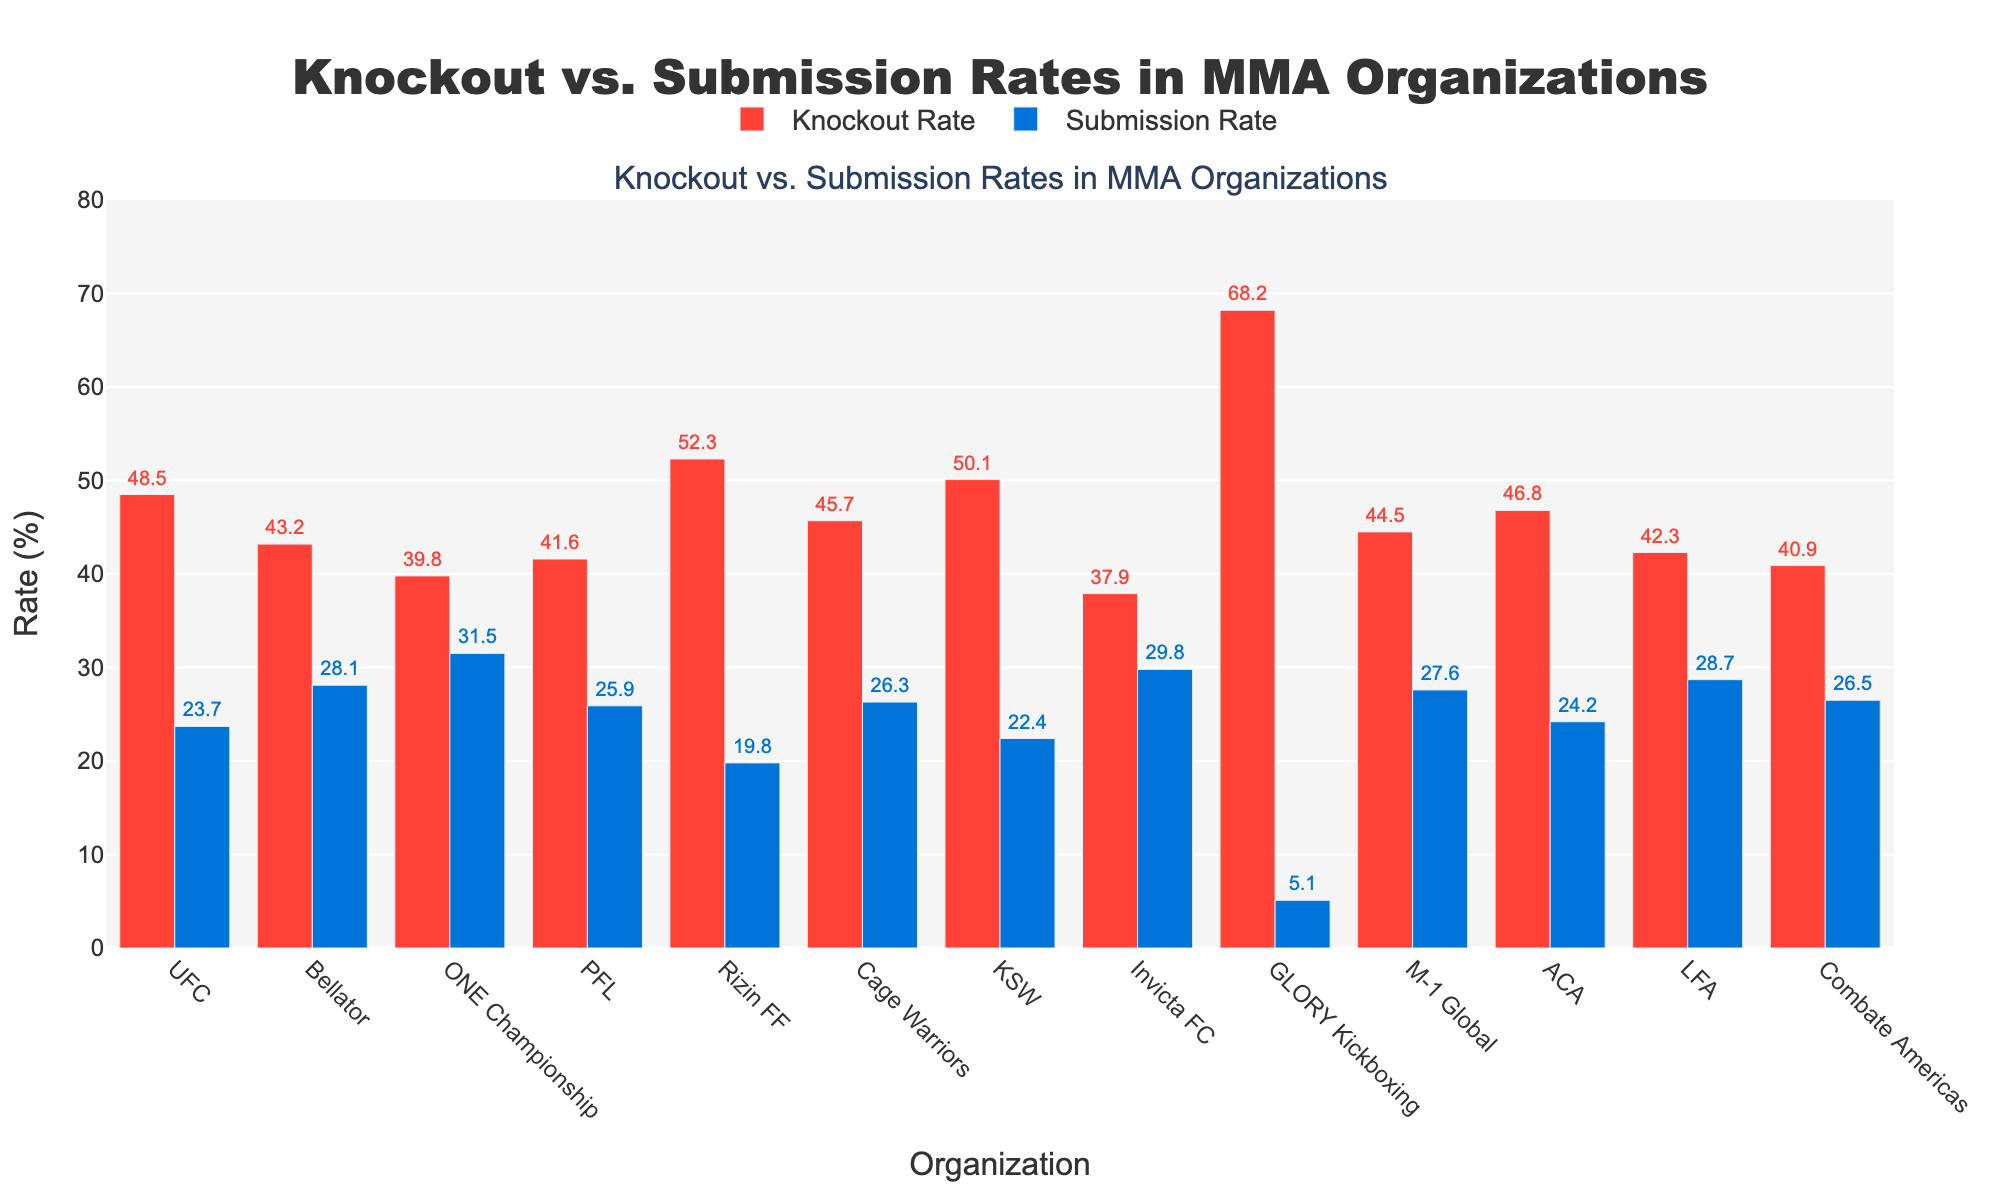Which organization has the highest knockout rate? GLORY Kickboxing has the highest knockout rate at 68.2%. This is evident as the red bar is the tallest among all the knockout rates for the organizations listed.
Answer: GLORY Kickboxing Which organization has the lowest submission rate? The organization with the lowest submission rate is GLORY Kickboxing, with a 5.1% submission rate. This is clear because the blue bar for submission rate is the shortest for GLORY Kickboxing among all organizations.
Answer: GLORY Kickboxing What is the difference in knockout rates between Rizin FF and ONE Championship? The knockout rate for Rizin FF is 52.3%, and for ONE Championship, it is 39.8%. The difference is calculated by subtracting ONE Championship’s rate from Rizin FF’s rate: 52.3 - 39.8 = 12.5%.
Answer: 12.5% Which has a higher submission rate, Bellator or Invicta FC? Comparing the submission rates, Bellator has a submission rate of 28.1%, whereas Invicta FC has a rate of 29.8%. Thus, Invicta FC has a higher submission rate.
Answer: Invicta FC How much higher is the knockout rate of KSW compared to PFL? The knockout rate for KSW is 50.1%, and for PFL, it is 41.6%. The difference is calculated as 50.1 - 41.6 = 8.5%.
Answer: 8.5% What is the average knockout rate for all the organizations combined? The knockout rates are summed up as 48.5 + 43.2 + 39.8 + 41.6 + 52.3 + 45.7 + 50.1 + 37.9 + 68.2 + 44.5 + 46.8 + 42.3 + 40.9 = 601.8. Considering there are 13 organizations, the average is 601.8 / 13 = 46.3%.
Answer: 46.3% Is there any organization where the submission rate exceeds the knockout rate? Observing the bars, in all organizations, the red bar (knockout rate) is larger than the blue bar (submission rate), indicating that the submission rate does not exceed the knockout rate for any organization.
Answer: No Which organization has the widest gap between knockout and submission rates? To find the widest gap, calculate the difference for each organization. GLORY Kickboxing shows the largest difference at 68.2% - 5.1% = 63.1%.
Answer: GLORY Kickboxing 